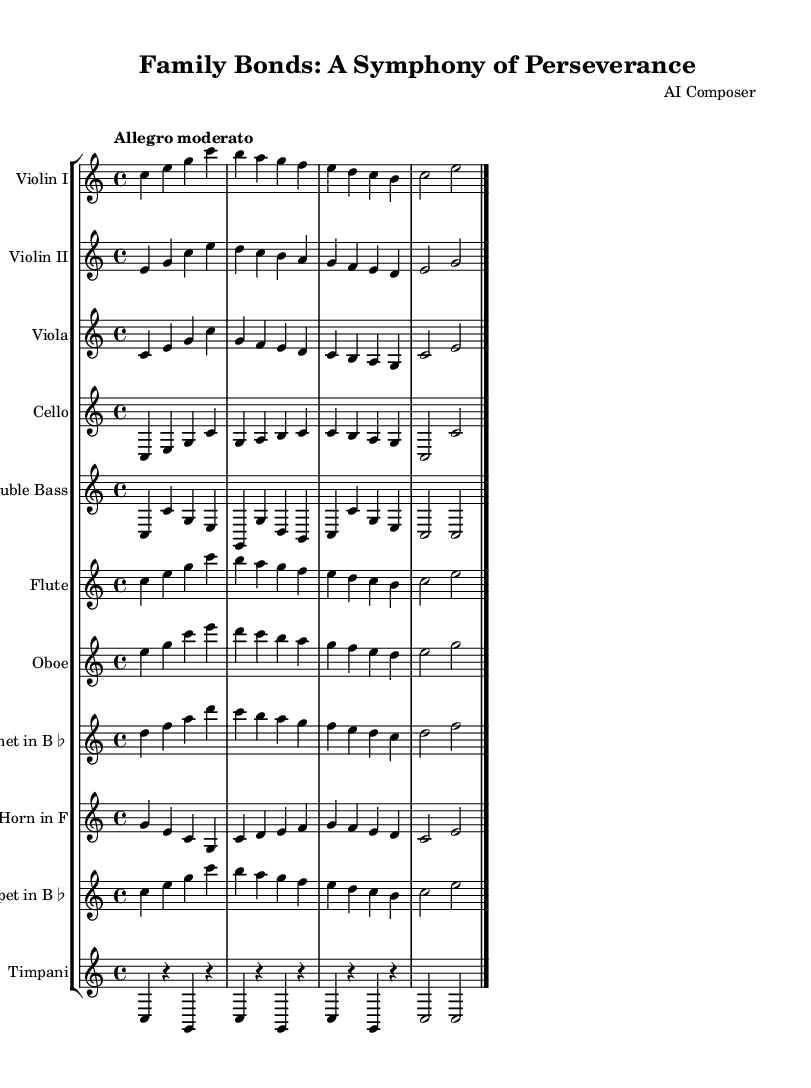What is the key signature of this music? The key signature is identified at the beginning of the sheet music where the key of C major is indicated. C major has no sharps or flats in its key signature.
Answer: C major What is the time signature of this music? The time signature is found at the beginning as well, represented by the fraction indicating the beats per measure. The notation says 4 over 4, meaning there are four beats in each measure.
Answer: 4/4 What is the tempo marking for this music? The tempo marking is listed at the beginning of the score. It indicates "Allegro moderato," which provides guidance on the speed of the music—moderately fast.
Answer: Allegro moderato How many instruments are featured in this score? By counting the distinct staves for each instrument in the score section, we note that there are eleven different instruments listed, including strings, woodwinds, and brass.
Answer: Eleven Which instrument plays the highest pitch in this score? The violin typically has the highest pitch range among the instruments listed. In this score, Violin I clearly plays the highest notes relative to the other instruments.
Answer: Violin I What melodic relationship do the flute and oboe have in measure 1? In the first measure, the flute and oboe play complementary melodies that align rhythmically and harmonically, establishing a unity in texture and showcasing their interplay.
Answer: Complementary melodies How does the timpani contribute to the overall texture of this piece? The timpani provides rhythmic support and accents at pivotal moments in the score, creating a foundation upon which the melodic instruments build their themes, enhancing the piece's dynamic quality.
Answer: Rhythmic support 